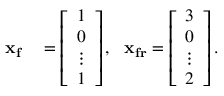Convert formula to latex. <formula><loc_0><loc_0><loc_500><loc_500>\begin{array} { r l } { x _ { f } } & = \left [ \begin{array} { l } { 1 } \\ { 0 } \\ { \vdots } \\ { 1 } \end{array} \right ] , \, x _ { f r } = \left [ \begin{array} { l } { 3 } \\ { 0 } \\ { \vdots } \\ { 2 } \end{array} \right ] . } \end{array}</formula> 